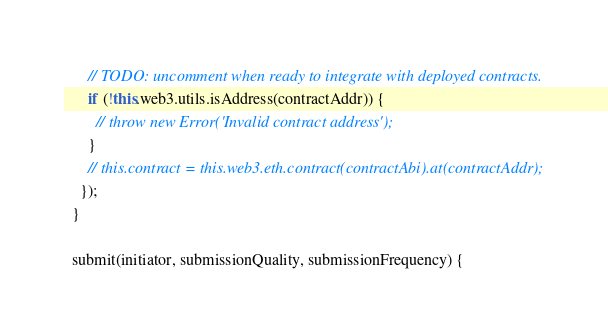Convert code to text. <code><loc_0><loc_0><loc_500><loc_500><_JavaScript_>      // TODO: uncomment when ready to integrate with deployed contracts.
      if (!this.web3.utils.isAddress(contractAddr)) {
        // throw new Error('Invalid contract address');
      }
      // this.contract = this.web3.eth.contract(contractAbi).at(contractAddr);
    });
  }

  submit(initiator, submissionQuality, submissionFrequency) {</code> 